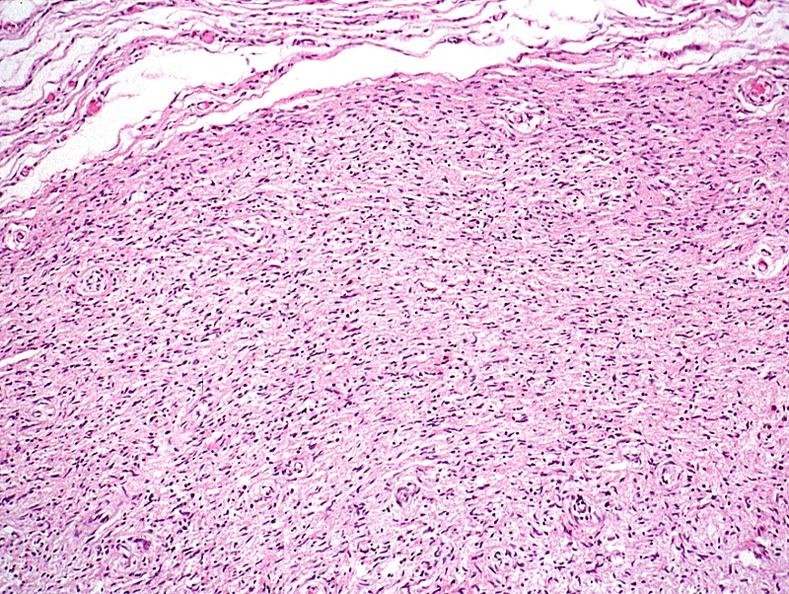where is this?
Answer the question using a single word or phrase. Skin 